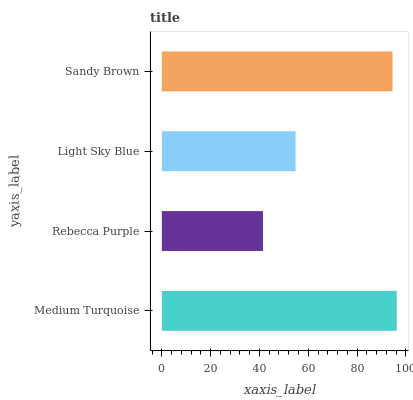Is Rebecca Purple the minimum?
Answer yes or no. Yes. Is Medium Turquoise the maximum?
Answer yes or no. Yes. Is Light Sky Blue the minimum?
Answer yes or no. No. Is Light Sky Blue the maximum?
Answer yes or no. No. Is Light Sky Blue greater than Rebecca Purple?
Answer yes or no. Yes. Is Rebecca Purple less than Light Sky Blue?
Answer yes or no. Yes. Is Rebecca Purple greater than Light Sky Blue?
Answer yes or no. No. Is Light Sky Blue less than Rebecca Purple?
Answer yes or no. No. Is Sandy Brown the high median?
Answer yes or no. Yes. Is Light Sky Blue the low median?
Answer yes or no. Yes. Is Medium Turquoise the high median?
Answer yes or no. No. Is Rebecca Purple the low median?
Answer yes or no. No. 